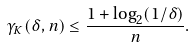<formula> <loc_0><loc_0><loc_500><loc_500>\gamma _ { K } ( \delta , n ) \leq \frac { 1 + \log _ { 2 } ( 1 / \delta ) } { n } .</formula> 